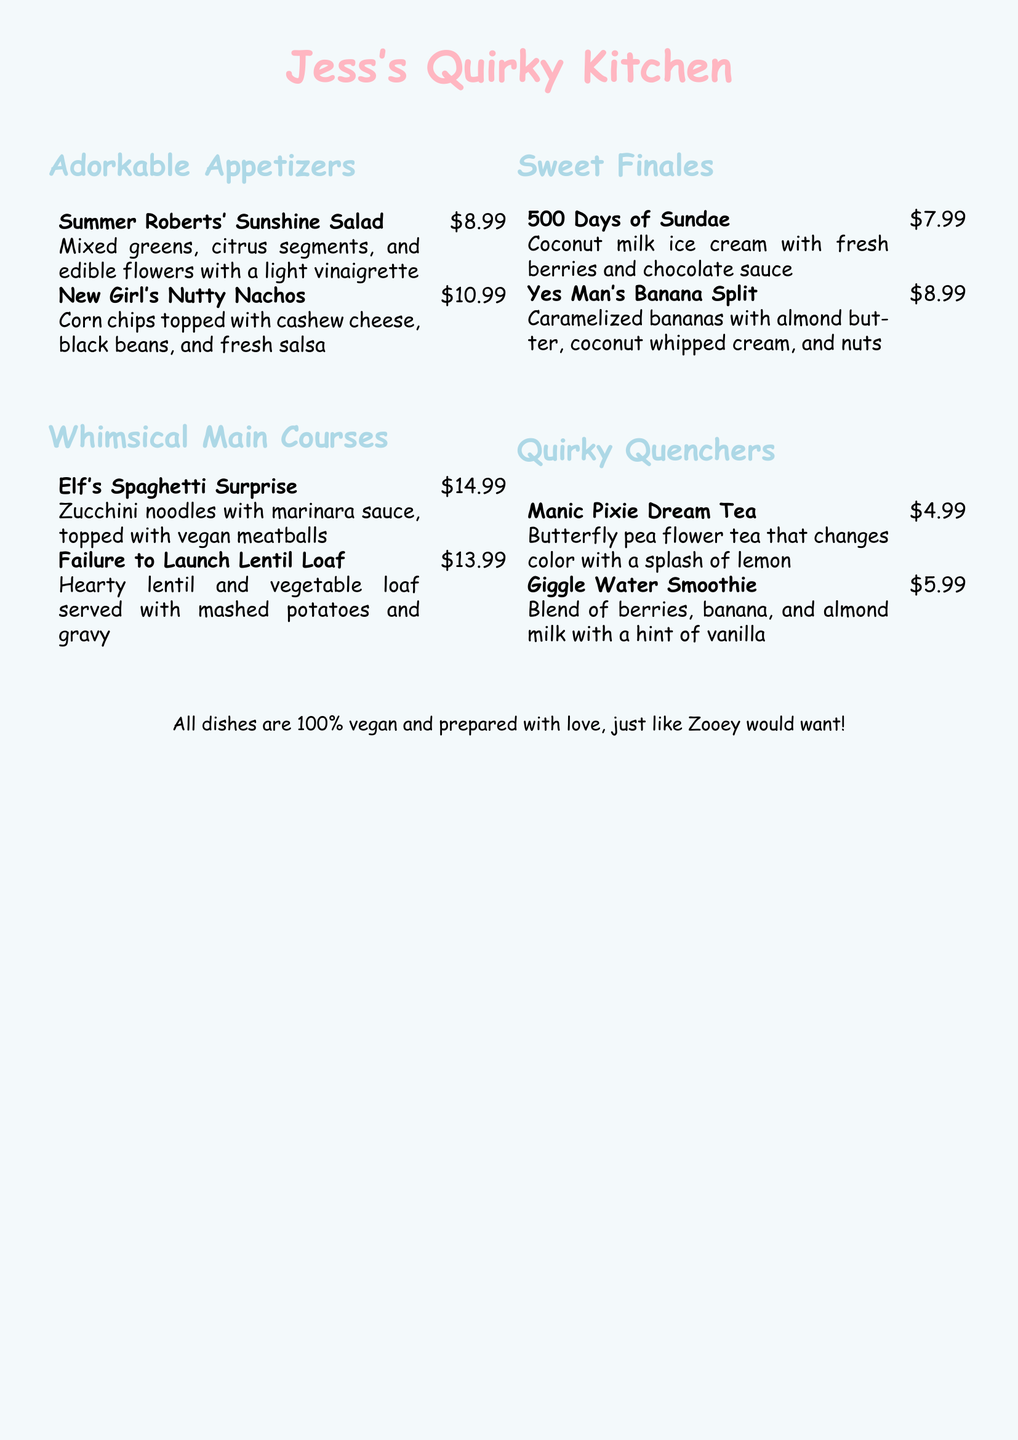What is the name of the first appetizer? The first appetizer listed in the menu is "Summer Roberts' Sunshine Salad."
Answer: Summer Roberts' Sunshine Salad How much does the "Failure to Launch Lentil Loaf" cost? The cost of the "Failure to Launch Lentil Loaf" is stated in the menu as $13.99.
Answer: $13.99 What type of cuisine does Jess's Quirky Kitchen offer? The menu specifies that all dishes are 100% vegan.
Answer: vegan How many sweet finales are listed on the menu? There are two sweet finales listed under the "Sweet Finales" section.
Answer: 2 What main course features zucchini noodles? The main course featuring zucchini noodles is "Elf's Spaghetti Surprise."
Answer: Elf's Spaghetti Surprise Which drink changes color with lemon? The drink that changes color with a splash of lemon is "Manic Pixie Dream Tea."
Answer: Manic Pixie Dream Tea What ingredient is shared between the "Yes Man's Banana Split" and "Giggle Water Smoothie"? Both the "Yes Man's Banana Split" and "Giggle Water Smoothie" contain bananas.
Answer: bananas How many appetizers are on the menu? There are two appetizers listed in the "Adorkable Appetizers" section.
Answer: 2 What is the price of "500 Days of Sundae"? The price listed for "500 Days of Sundae" is $7.99.
Answer: $7.99 